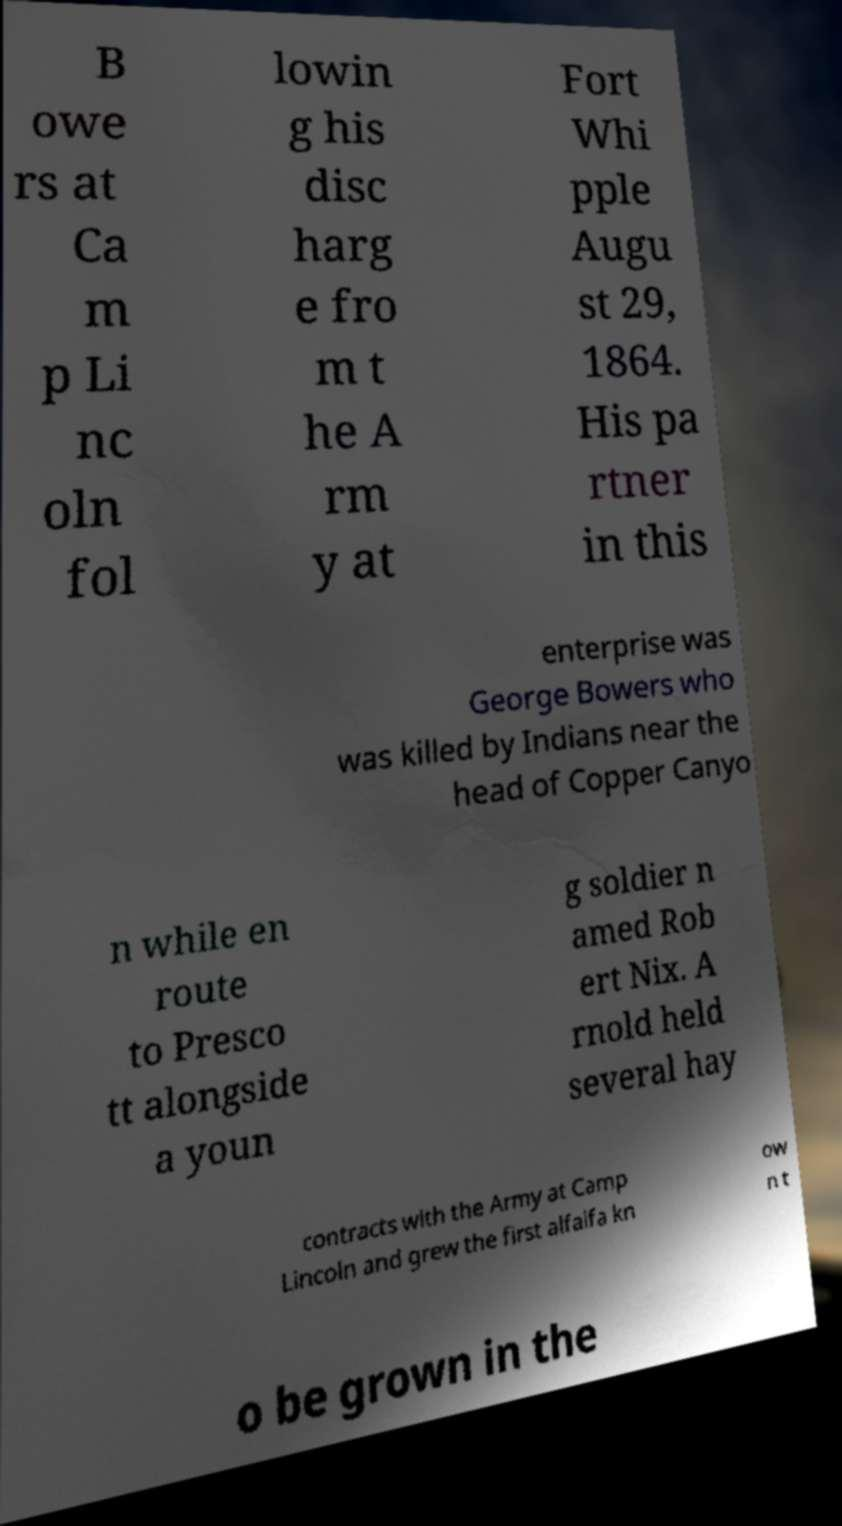I need the written content from this picture converted into text. Can you do that? B owe rs at Ca m p Li nc oln fol lowin g his disc harg e fro m t he A rm y at Fort Whi pple Augu st 29, 1864. His pa rtner in this enterprise was George Bowers who was killed by Indians near the head of Copper Canyo n while en route to Presco tt alongside a youn g soldier n amed Rob ert Nix. A rnold held several hay contracts with the Army at Camp Lincoln and grew the first alfalfa kn ow n t o be grown in the 